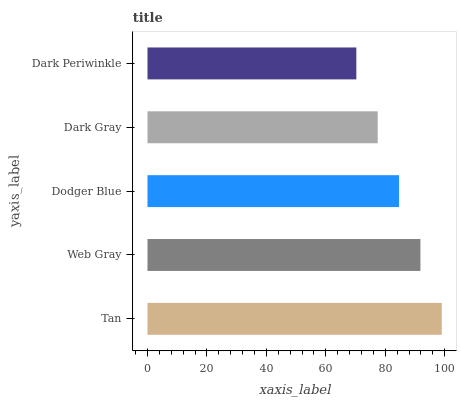Is Dark Periwinkle the minimum?
Answer yes or no. Yes. Is Tan the maximum?
Answer yes or no. Yes. Is Web Gray the minimum?
Answer yes or no. No. Is Web Gray the maximum?
Answer yes or no. No. Is Tan greater than Web Gray?
Answer yes or no. Yes. Is Web Gray less than Tan?
Answer yes or no. Yes. Is Web Gray greater than Tan?
Answer yes or no. No. Is Tan less than Web Gray?
Answer yes or no. No. Is Dodger Blue the high median?
Answer yes or no. Yes. Is Dodger Blue the low median?
Answer yes or no. Yes. Is Web Gray the high median?
Answer yes or no. No. Is Tan the low median?
Answer yes or no. No. 